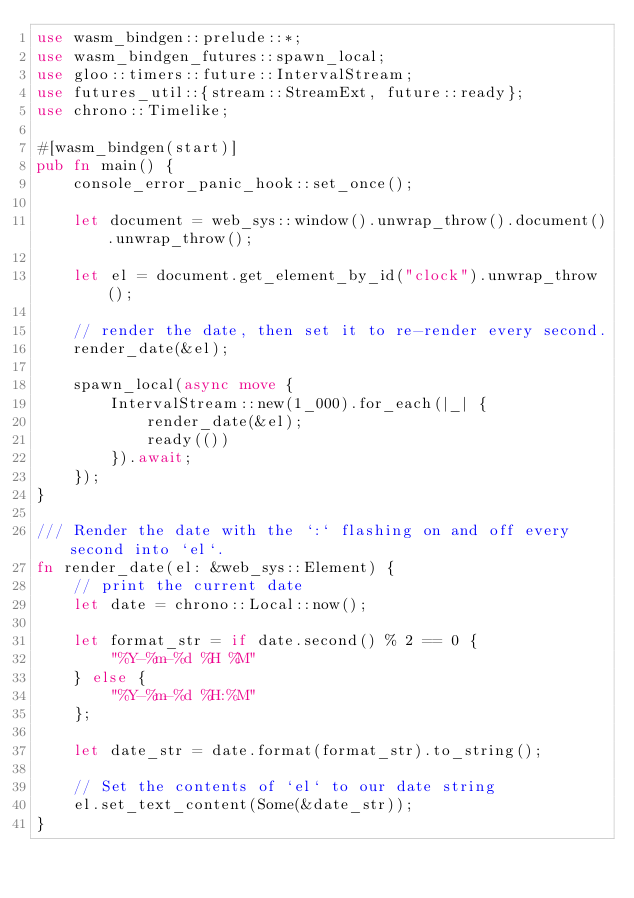<code> <loc_0><loc_0><loc_500><loc_500><_Rust_>use wasm_bindgen::prelude::*;
use wasm_bindgen_futures::spawn_local;
use gloo::timers::future::IntervalStream;
use futures_util::{stream::StreamExt, future::ready};
use chrono::Timelike;

#[wasm_bindgen(start)]
pub fn main() {
    console_error_panic_hook::set_once();

    let document = web_sys::window().unwrap_throw().document().unwrap_throw();

    let el = document.get_element_by_id("clock").unwrap_throw();

    // render the date, then set it to re-render every second.
    render_date(&el);

    spawn_local(async move {
        IntervalStream::new(1_000).for_each(|_| {
            render_date(&el);
            ready(())
        }).await;
    });
}

/// Render the date with the `:` flashing on and off every second into `el`.
fn render_date(el: &web_sys::Element) {
    // print the current date
    let date = chrono::Local::now();

    let format_str = if date.second() % 2 == 0 {
        "%Y-%m-%d %H %M"
    } else {
        "%Y-%m-%d %H:%M"
    };

    let date_str = date.format(format_str).to_string();

    // Set the contents of `el` to our date string
    el.set_text_content(Some(&date_str));
}
</code> 